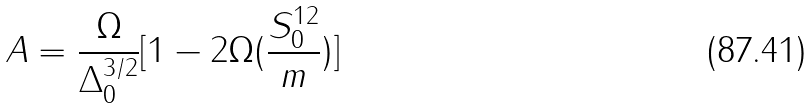Convert formula to latex. <formula><loc_0><loc_0><loc_500><loc_500>A = \frac { \Omega } { \Delta _ { 0 } ^ { 3 / 2 } } [ 1 - 2 \Omega ( \frac { S _ { 0 } ^ { 1 2 } } { m } ) ]</formula> 